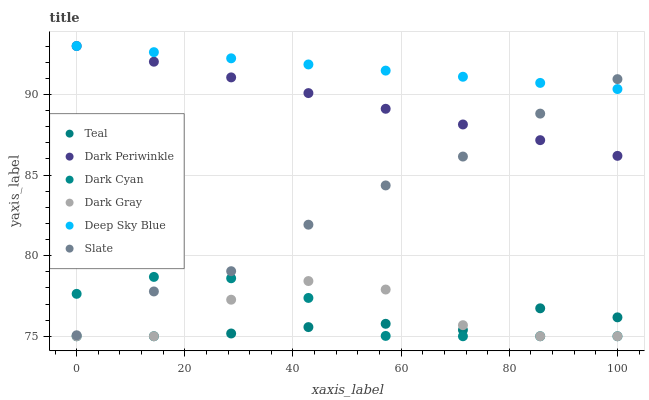Does Teal have the minimum area under the curve?
Answer yes or no. Yes. Does Deep Sky Blue have the maximum area under the curve?
Answer yes or no. Yes. Does Slate have the minimum area under the curve?
Answer yes or no. No. Does Slate have the maximum area under the curve?
Answer yes or no. No. Is Dark Periwinkle the smoothest?
Answer yes or no. Yes. Is Dark Gray the roughest?
Answer yes or no. Yes. Is Slate the smoothest?
Answer yes or no. No. Is Slate the roughest?
Answer yes or no. No. Does Dark Gray have the lowest value?
Answer yes or no. Yes. Does Slate have the lowest value?
Answer yes or no. No. Does Dark Periwinkle have the highest value?
Answer yes or no. Yes. Does Slate have the highest value?
Answer yes or no. No. Is Teal less than Dark Periwinkle?
Answer yes or no. Yes. Is Dark Periwinkle greater than Dark Gray?
Answer yes or no. Yes. Does Dark Cyan intersect Slate?
Answer yes or no. Yes. Is Dark Cyan less than Slate?
Answer yes or no. No. Is Dark Cyan greater than Slate?
Answer yes or no. No. Does Teal intersect Dark Periwinkle?
Answer yes or no. No. 